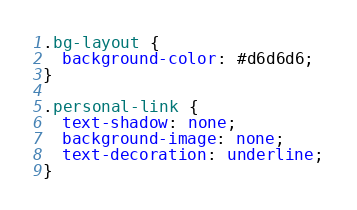Convert code to text. <code><loc_0><loc_0><loc_500><loc_500><_CSS_>.bg-layout {
  background-color: #d6d6d6;
}

.personal-link {
  text-shadow: none;
  background-image: none;
  text-decoration: underline;
}
</code> 